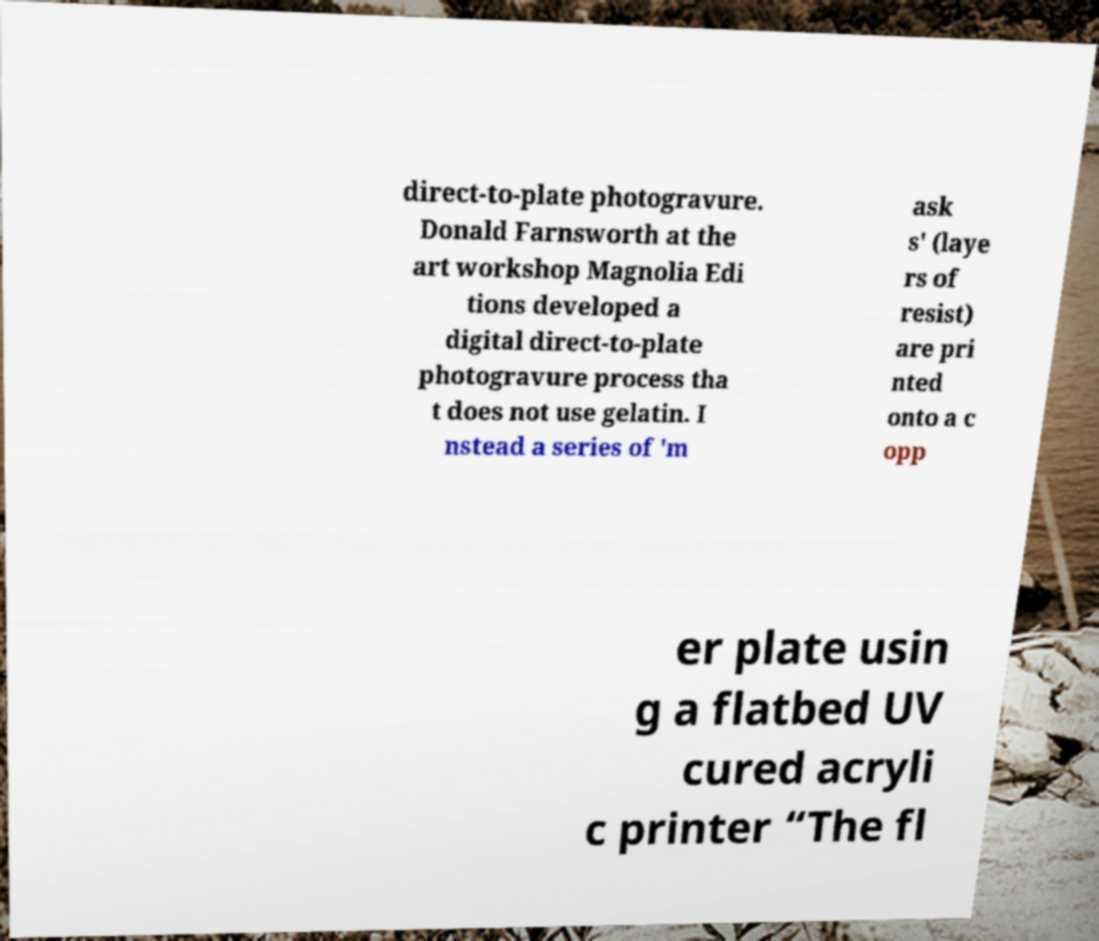Please read and relay the text visible in this image. What does it say? direct-to-plate photogravure. Donald Farnsworth at the art workshop Magnolia Edi tions developed a digital direct-to-plate photogravure process tha t does not use gelatin. I nstead a series of 'm ask s' (laye rs of resist) are pri nted onto a c opp er plate usin g a flatbed UV cured acryli c printer “The fl 